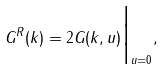<formula> <loc_0><loc_0><loc_500><loc_500>G ^ { R } ( k ) = 2 G ( k , u ) \Big | _ { u = 0 } ,</formula> 